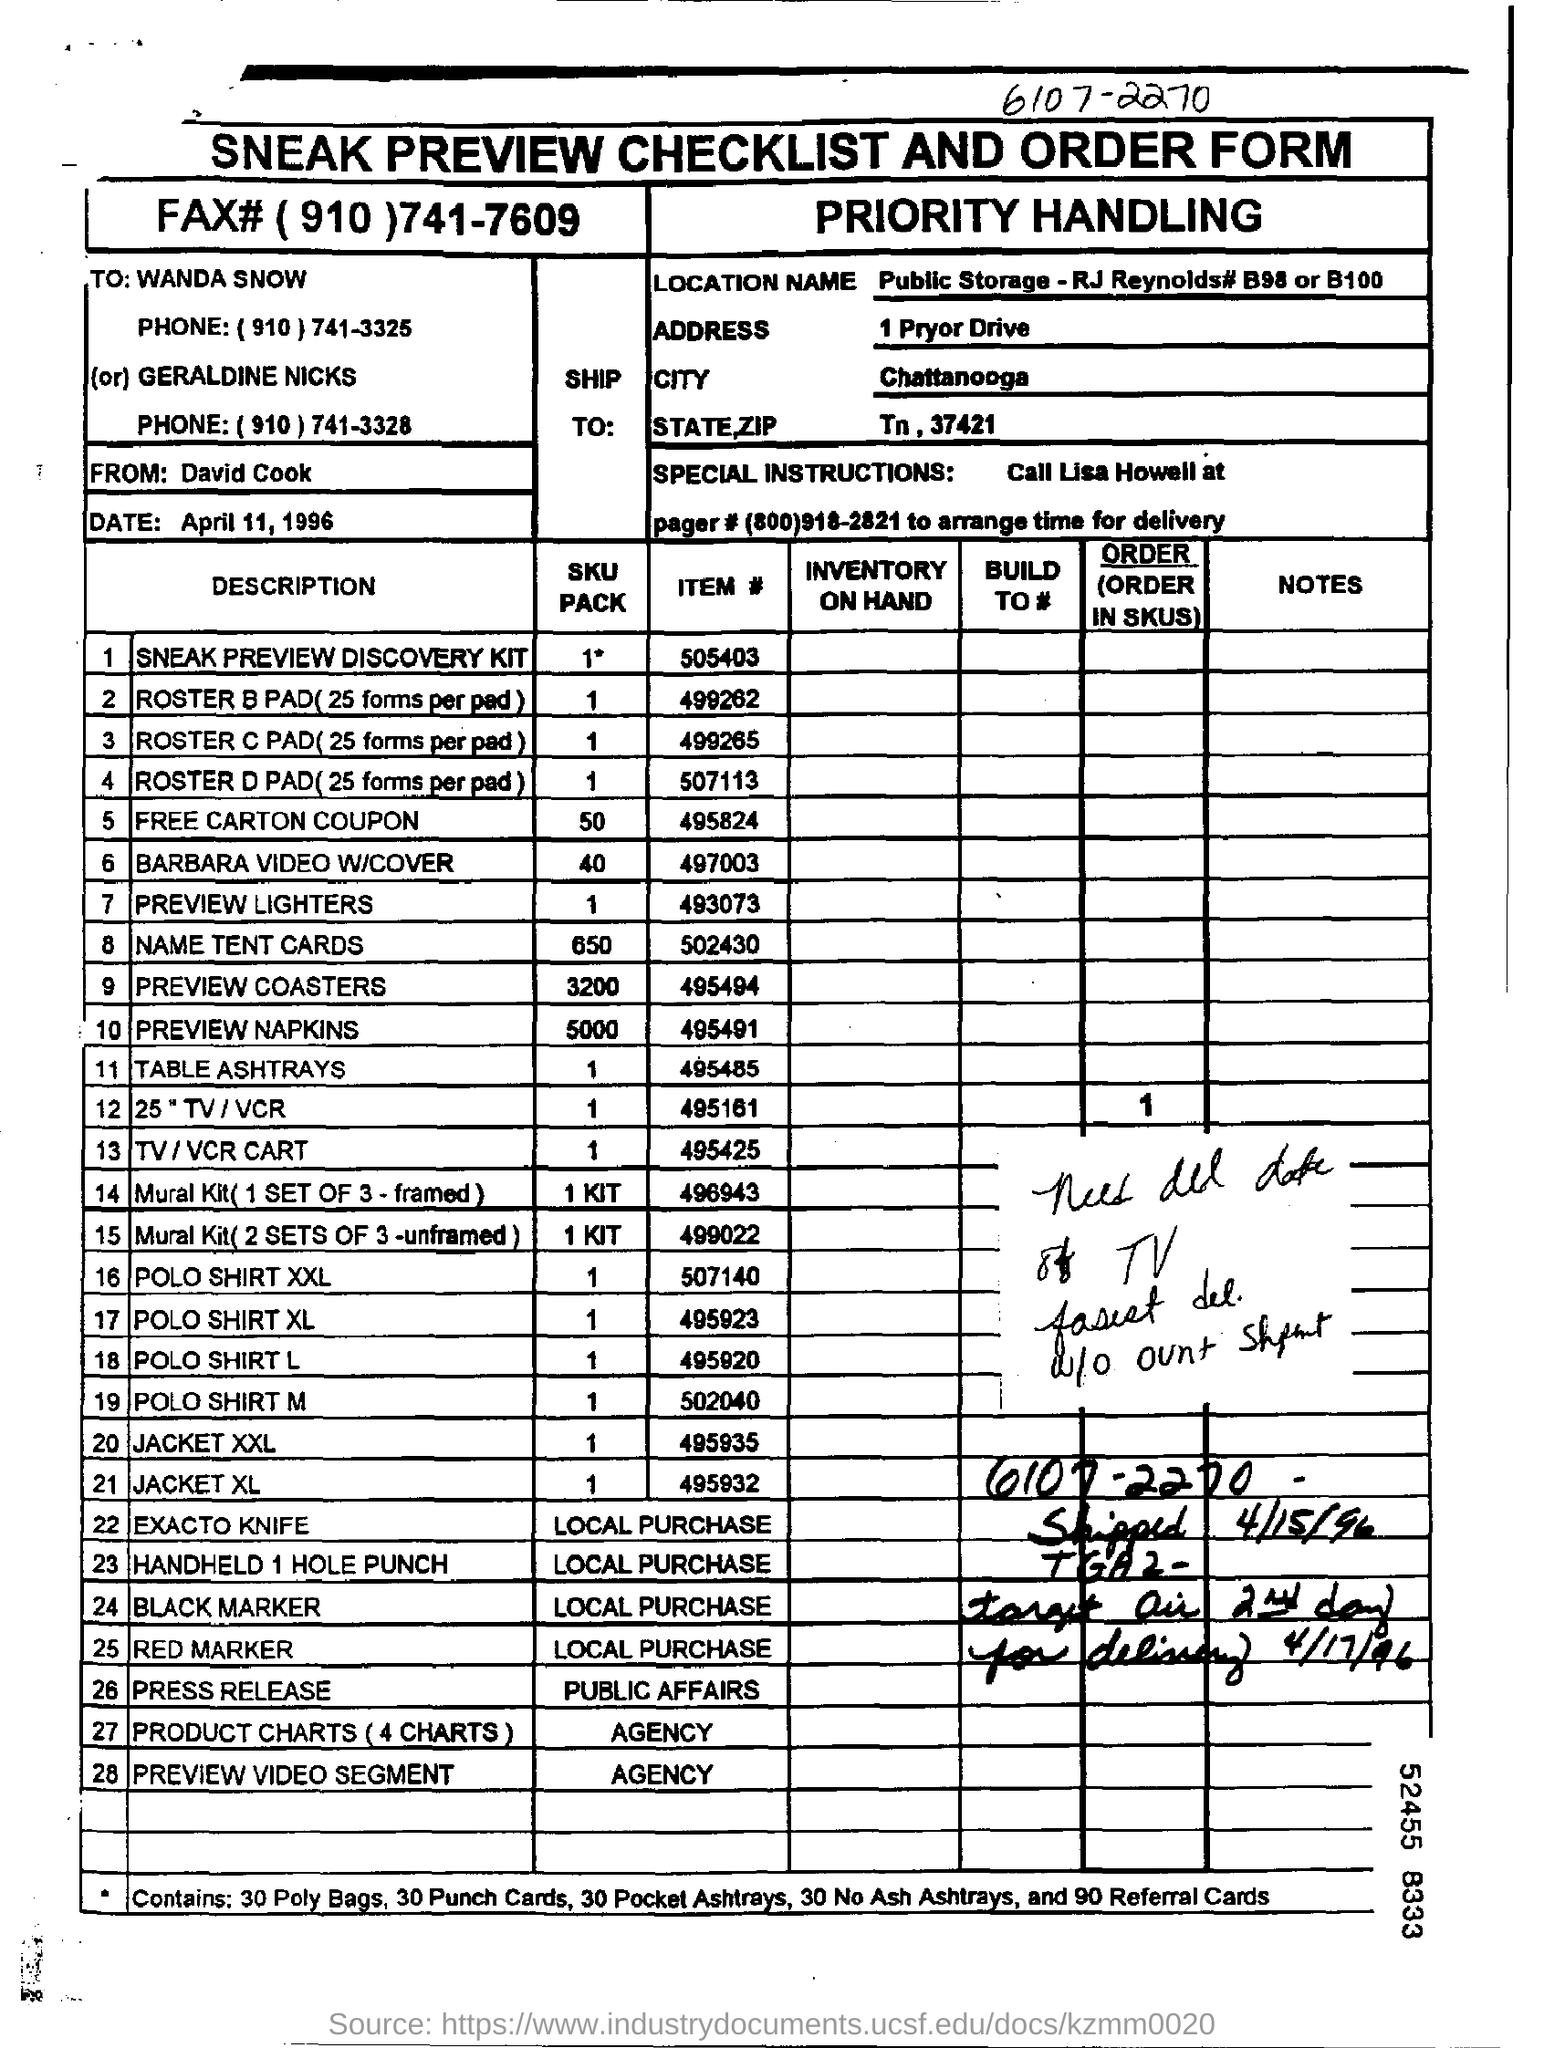Who is the sender of this form?
Provide a succinct answer. David Cook. Who is it addressed to?
Keep it short and to the point. Wanda Snow. What is the address?
Give a very brief answer. 1 Pryor Drive. What is the city?
Ensure brevity in your answer.  Chattanooga. What is the state,zip?
Make the answer very short. Tn, 37421. Who is it From?
Keep it short and to the point. David Cook. What is the Date?
Ensure brevity in your answer.  April 11, 1996. What is the SKU Pack for Item # 495824?
Offer a very short reply. 50. What is the SKU Pack for Item # 497003?
Give a very brief answer. 40. What is the SKU Pack for Item # 502430?
Provide a succinct answer. 650. 